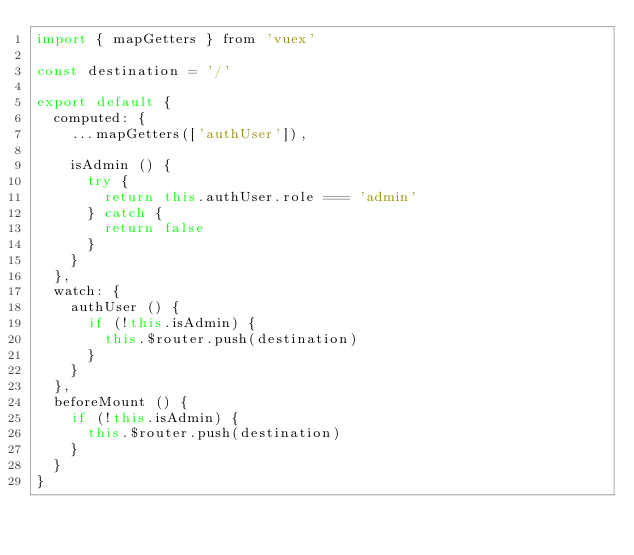<code> <loc_0><loc_0><loc_500><loc_500><_JavaScript_>import { mapGetters } from 'vuex'

const destination = '/'

export default {
  computed: {
    ...mapGetters(['authUser']),

    isAdmin () {
      try {
        return this.authUser.role === 'admin'
      } catch {
        return false
      }
    }
  },
  watch: {
    authUser () {
      if (!this.isAdmin) {
        this.$router.push(destination)
      }
    }
  },
  beforeMount () {
    if (!this.isAdmin) {
      this.$router.push(destination)
    }
  }
}
</code> 